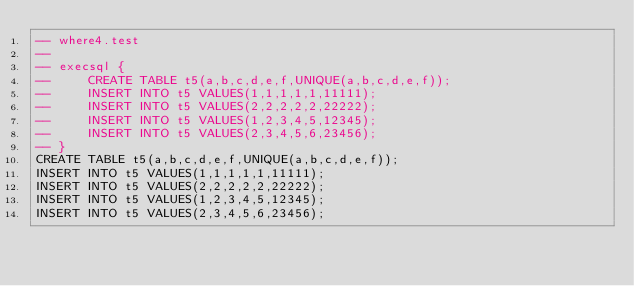Convert code to text. <code><loc_0><loc_0><loc_500><loc_500><_SQL_>-- where4.test
-- 
-- execsql {
--     CREATE TABLE t5(a,b,c,d,e,f,UNIQUE(a,b,c,d,e,f));
--     INSERT INTO t5 VALUES(1,1,1,1,1,11111);
--     INSERT INTO t5 VALUES(2,2,2,2,2,22222);
--     INSERT INTO t5 VALUES(1,2,3,4,5,12345);
--     INSERT INTO t5 VALUES(2,3,4,5,6,23456);
-- }
CREATE TABLE t5(a,b,c,d,e,f,UNIQUE(a,b,c,d,e,f));
INSERT INTO t5 VALUES(1,1,1,1,1,11111);
INSERT INTO t5 VALUES(2,2,2,2,2,22222);
INSERT INTO t5 VALUES(1,2,3,4,5,12345);
INSERT INTO t5 VALUES(2,3,4,5,6,23456);</code> 